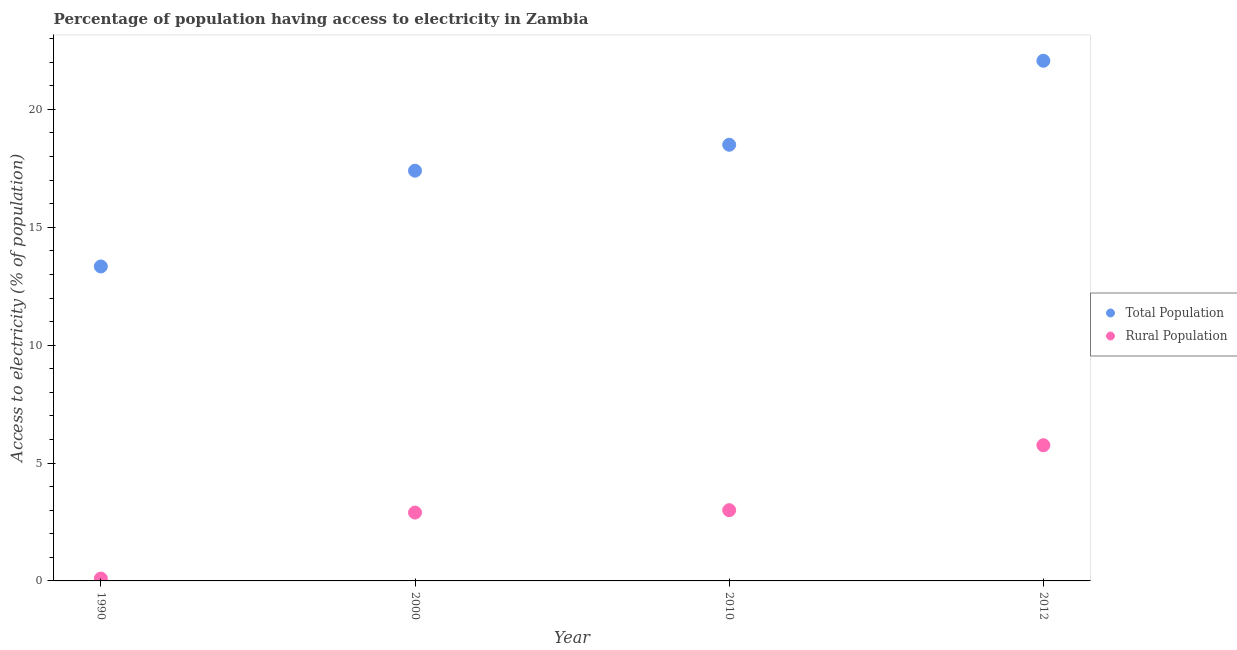How many different coloured dotlines are there?
Offer a very short reply. 2. What is the percentage of rural population having access to electricity in 2010?
Give a very brief answer. 3. Across all years, what is the maximum percentage of rural population having access to electricity?
Offer a very short reply. 5.75. In which year was the percentage of rural population having access to electricity maximum?
Offer a terse response. 2012. What is the total percentage of rural population having access to electricity in the graph?
Your answer should be very brief. 11.75. What is the difference between the percentage of rural population having access to electricity in 1990 and that in 2012?
Give a very brief answer. -5.65. What is the difference between the percentage of rural population having access to electricity in 2010 and the percentage of population having access to electricity in 1990?
Your answer should be compact. -10.34. What is the average percentage of rural population having access to electricity per year?
Offer a terse response. 2.94. In the year 2010, what is the difference between the percentage of rural population having access to electricity and percentage of population having access to electricity?
Your response must be concise. -15.5. In how many years, is the percentage of rural population having access to electricity greater than 21 %?
Keep it short and to the point. 0. What is the ratio of the percentage of population having access to electricity in 2000 to that in 2010?
Offer a terse response. 0.94. What is the difference between the highest and the second highest percentage of population having access to electricity?
Provide a short and direct response. 3.56. What is the difference between the highest and the lowest percentage of population having access to electricity?
Keep it short and to the point. 8.72. How many years are there in the graph?
Make the answer very short. 4. Does the graph contain grids?
Provide a short and direct response. No. Where does the legend appear in the graph?
Your answer should be compact. Center right. What is the title of the graph?
Offer a very short reply. Percentage of population having access to electricity in Zambia. What is the label or title of the Y-axis?
Make the answer very short. Access to electricity (% of population). What is the Access to electricity (% of population) of Total Population in 1990?
Offer a very short reply. 13.34. What is the Access to electricity (% of population) of Total Population in 2010?
Your response must be concise. 18.5. What is the Access to electricity (% of population) in Total Population in 2012?
Ensure brevity in your answer.  22.06. What is the Access to electricity (% of population) of Rural Population in 2012?
Provide a short and direct response. 5.75. Across all years, what is the maximum Access to electricity (% of population) of Total Population?
Provide a short and direct response. 22.06. Across all years, what is the maximum Access to electricity (% of population) in Rural Population?
Keep it short and to the point. 5.75. Across all years, what is the minimum Access to electricity (% of population) in Total Population?
Make the answer very short. 13.34. Across all years, what is the minimum Access to electricity (% of population) of Rural Population?
Your response must be concise. 0.1. What is the total Access to electricity (% of population) in Total Population in the graph?
Provide a short and direct response. 71.3. What is the total Access to electricity (% of population) in Rural Population in the graph?
Your answer should be compact. 11.75. What is the difference between the Access to electricity (% of population) of Total Population in 1990 and that in 2000?
Your answer should be compact. -4.06. What is the difference between the Access to electricity (% of population) in Rural Population in 1990 and that in 2000?
Offer a very short reply. -2.8. What is the difference between the Access to electricity (% of population) of Total Population in 1990 and that in 2010?
Offer a terse response. -5.16. What is the difference between the Access to electricity (% of population) of Rural Population in 1990 and that in 2010?
Ensure brevity in your answer.  -2.9. What is the difference between the Access to electricity (% of population) in Total Population in 1990 and that in 2012?
Provide a succinct answer. -8.72. What is the difference between the Access to electricity (% of population) in Rural Population in 1990 and that in 2012?
Your answer should be very brief. -5.65. What is the difference between the Access to electricity (% of population) in Total Population in 2000 and that in 2010?
Your answer should be very brief. -1.1. What is the difference between the Access to electricity (% of population) of Rural Population in 2000 and that in 2010?
Your answer should be very brief. -0.1. What is the difference between the Access to electricity (% of population) in Total Population in 2000 and that in 2012?
Ensure brevity in your answer.  -4.66. What is the difference between the Access to electricity (% of population) of Rural Population in 2000 and that in 2012?
Your answer should be very brief. -2.85. What is the difference between the Access to electricity (% of population) in Total Population in 2010 and that in 2012?
Give a very brief answer. -3.56. What is the difference between the Access to electricity (% of population) of Rural Population in 2010 and that in 2012?
Give a very brief answer. -2.75. What is the difference between the Access to electricity (% of population) in Total Population in 1990 and the Access to electricity (% of population) in Rural Population in 2000?
Offer a terse response. 10.44. What is the difference between the Access to electricity (% of population) in Total Population in 1990 and the Access to electricity (% of population) in Rural Population in 2010?
Your answer should be compact. 10.34. What is the difference between the Access to electricity (% of population) in Total Population in 1990 and the Access to electricity (% of population) in Rural Population in 2012?
Ensure brevity in your answer.  7.58. What is the difference between the Access to electricity (% of population) of Total Population in 2000 and the Access to electricity (% of population) of Rural Population in 2010?
Your response must be concise. 14.4. What is the difference between the Access to electricity (% of population) in Total Population in 2000 and the Access to electricity (% of population) in Rural Population in 2012?
Your response must be concise. 11.65. What is the difference between the Access to electricity (% of population) in Total Population in 2010 and the Access to electricity (% of population) in Rural Population in 2012?
Your response must be concise. 12.75. What is the average Access to electricity (% of population) in Total Population per year?
Provide a succinct answer. 17.83. What is the average Access to electricity (% of population) in Rural Population per year?
Provide a short and direct response. 2.94. In the year 1990, what is the difference between the Access to electricity (% of population) in Total Population and Access to electricity (% of population) in Rural Population?
Provide a succinct answer. 13.24. In the year 2012, what is the difference between the Access to electricity (% of population) in Total Population and Access to electricity (% of population) in Rural Population?
Offer a very short reply. 16.31. What is the ratio of the Access to electricity (% of population) of Total Population in 1990 to that in 2000?
Keep it short and to the point. 0.77. What is the ratio of the Access to electricity (% of population) in Rural Population in 1990 to that in 2000?
Your answer should be compact. 0.03. What is the ratio of the Access to electricity (% of population) of Total Population in 1990 to that in 2010?
Keep it short and to the point. 0.72. What is the ratio of the Access to electricity (% of population) of Total Population in 1990 to that in 2012?
Ensure brevity in your answer.  0.6. What is the ratio of the Access to electricity (% of population) in Rural Population in 1990 to that in 2012?
Ensure brevity in your answer.  0.02. What is the ratio of the Access to electricity (% of population) of Total Population in 2000 to that in 2010?
Your response must be concise. 0.94. What is the ratio of the Access to electricity (% of population) in Rural Population in 2000 to that in 2010?
Keep it short and to the point. 0.97. What is the ratio of the Access to electricity (% of population) of Total Population in 2000 to that in 2012?
Offer a very short reply. 0.79. What is the ratio of the Access to electricity (% of population) in Rural Population in 2000 to that in 2012?
Your answer should be compact. 0.5. What is the ratio of the Access to electricity (% of population) of Total Population in 2010 to that in 2012?
Ensure brevity in your answer.  0.84. What is the ratio of the Access to electricity (% of population) in Rural Population in 2010 to that in 2012?
Provide a succinct answer. 0.52. What is the difference between the highest and the second highest Access to electricity (% of population) in Total Population?
Provide a short and direct response. 3.56. What is the difference between the highest and the second highest Access to electricity (% of population) in Rural Population?
Offer a very short reply. 2.75. What is the difference between the highest and the lowest Access to electricity (% of population) of Total Population?
Keep it short and to the point. 8.72. What is the difference between the highest and the lowest Access to electricity (% of population) of Rural Population?
Provide a succinct answer. 5.65. 